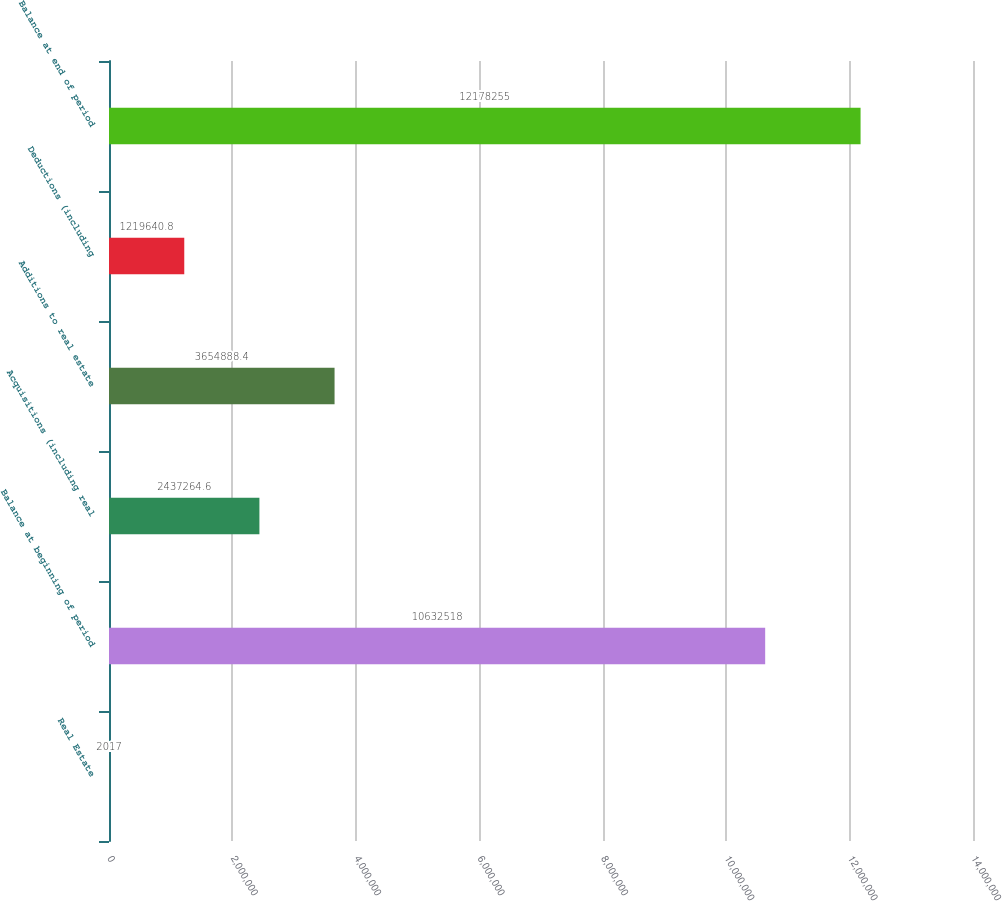Convert chart. <chart><loc_0><loc_0><loc_500><loc_500><bar_chart><fcel>Real Estate<fcel>Balance at beginning of period<fcel>Acquisitions (including real<fcel>Additions to real estate<fcel>Deductions (including<fcel>Balance at end of period<nl><fcel>2017<fcel>1.06325e+07<fcel>2.43726e+06<fcel>3.65489e+06<fcel>1.21964e+06<fcel>1.21783e+07<nl></chart> 